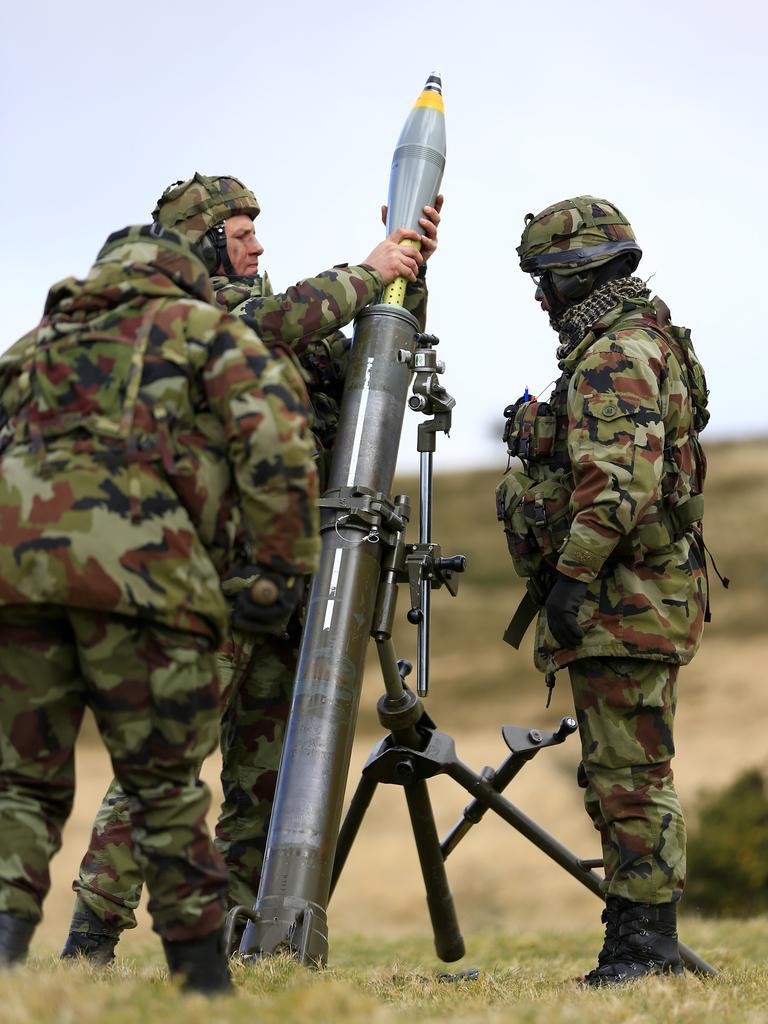How would you summarize this image in a sentence or two? These three people wore military dress and standing around this rocket. This is sand. One person is holding a rocket. Background it is blur. We can see the sky. 